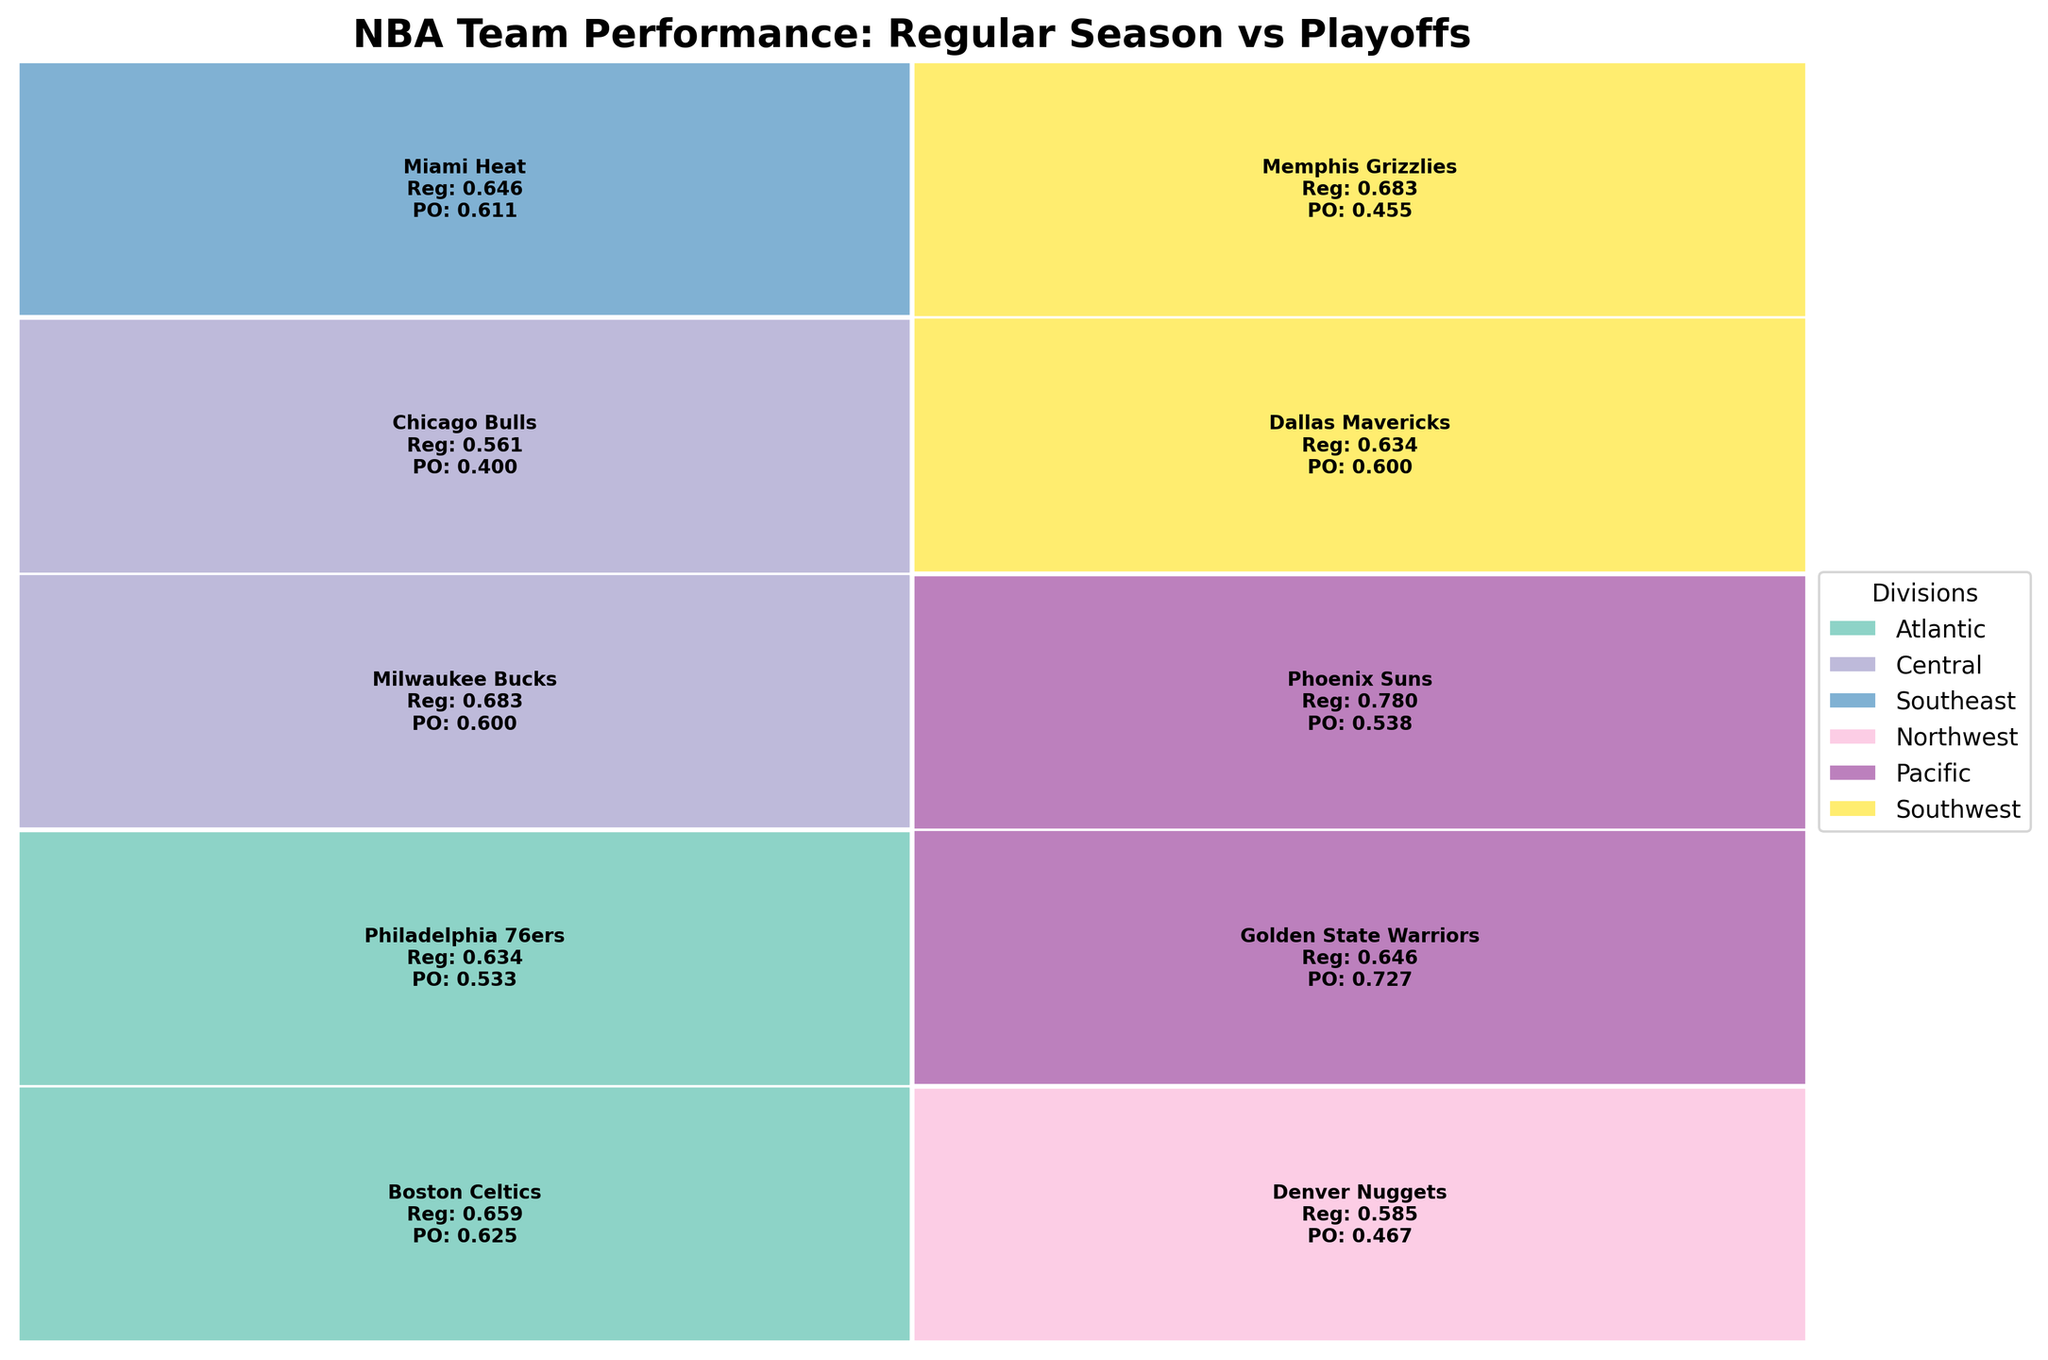How many divisions are there in the NBA according to the figure, and what are their colors? The legend shows different colors representing each division. By counting the distinct colors and names in the legend, we can identify the number of divisions and their corresponding colors.
Answer: There are 6 divisions: Atlantic, Central, Southeast, Northwest, Pacific, Southwest What is the title of the mosaic plot? The title is usually displayed at the top of the plot. By looking at the top, we can identify it.
Answer: NBA Team Performance: Regular Season vs Playoffs Which team has the highest regular season win rate? By comparing the 'Regular_Season_Win_Rate' values labeled next to each team in the figure, we can find the team with the highest rate.
Answer: Phoenix Suns Between the Golden State Warriors and the Boston Celtics, which team has a higher playoff win rate? Comparing the 'Playoff_Win_Rate' figures next to both teams, we can see which one is higher.
Answer: Golden State Warriors What's the difference in playoff win rate between the Eastern and Western Conferences? First, sum up the 'Playoff_Win_Rate' by conference, then calculate their difference. Western's total includes higher values from teams like Golden State Warriors. Summing up: Western (0.600+0.727+0.538+0.600+0.538), Eastern (0.625+0.533+0.600+0.400+0.611), resulting in Western having a total win rate advantage.
Answer: Western is higher Which division has the most teams with a playoff win rate less than 0.5? By examining each division and counting the number of teams with 'Playoff_Win_Rate' less than 0.5, the division with the highest count can be identified.
Answer: Northwest How does the regular season win rate of the Miami Heat compare to the Milwaukee Bucks? By examining the 'Regular_Season_Win_Rate' for each team, we can see if one is higher than the other.
Answer: Milwaukee Bucks have a higher rate Identify one team from each conference with the highest difference between regular season and playoff win rates. Calculate the difference between 'Regular_Season_Win_Rate' and 'Playoff_Win_Rate' for each team, then identify the team with the highest difference per conference.
Answer: Western: Memphis Grizzlies, Eastern: Chicago Bulls In which division do both teams have the same playoff win rate of 0.600? Look for 'Playoff_Win_Rate' values in each division that are identical and check if both are 0.600.
Answer: Central, with Milwaukee Bucks and Chicago Bulls 